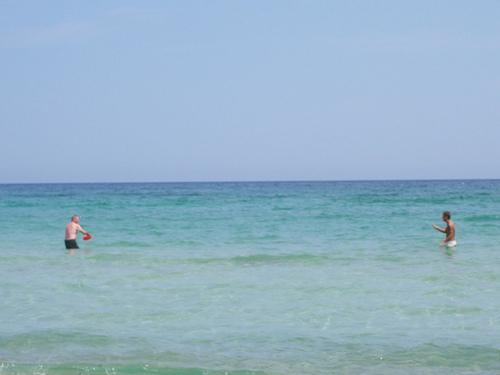Why does the man in white have his arm out? Please explain your reasoning. to catch. The man opposite to him is about the throw the frisbee. 